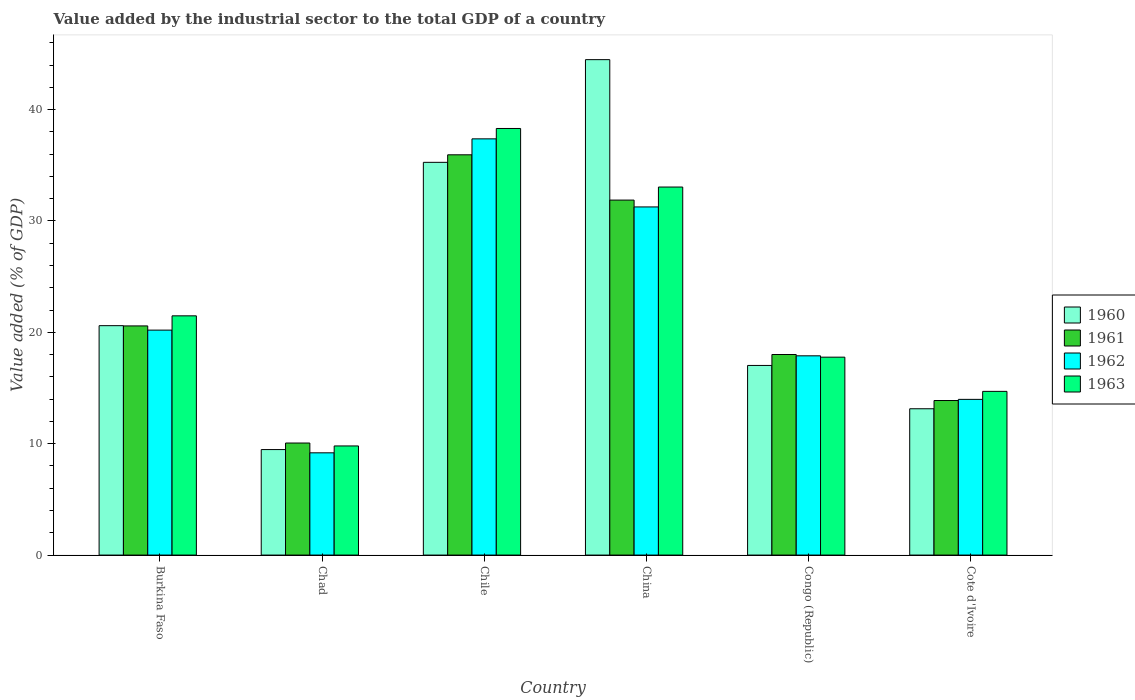How many groups of bars are there?
Provide a short and direct response. 6. Are the number of bars per tick equal to the number of legend labels?
Make the answer very short. Yes. How many bars are there on the 5th tick from the left?
Offer a terse response. 4. What is the value added by the industrial sector to the total GDP in 1961 in Chile?
Provide a short and direct response. 35.94. Across all countries, what is the maximum value added by the industrial sector to the total GDP in 1960?
Ensure brevity in your answer.  44.49. Across all countries, what is the minimum value added by the industrial sector to the total GDP in 1963?
Offer a terse response. 9.8. In which country was the value added by the industrial sector to the total GDP in 1960 minimum?
Make the answer very short. Chad. What is the total value added by the industrial sector to the total GDP in 1963 in the graph?
Your response must be concise. 135.11. What is the difference between the value added by the industrial sector to the total GDP in 1962 in Chile and that in China?
Your response must be concise. 6.11. What is the difference between the value added by the industrial sector to the total GDP in 1960 in Chile and the value added by the industrial sector to the total GDP in 1962 in Cote d'Ivoire?
Make the answer very short. 21.28. What is the average value added by the industrial sector to the total GDP in 1962 per country?
Your response must be concise. 21.65. What is the difference between the value added by the industrial sector to the total GDP of/in 1963 and value added by the industrial sector to the total GDP of/in 1960 in Chile?
Offer a very short reply. 3.04. In how many countries, is the value added by the industrial sector to the total GDP in 1961 greater than 14 %?
Your answer should be compact. 4. What is the ratio of the value added by the industrial sector to the total GDP in 1961 in Chile to that in China?
Offer a very short reply. 1.13. What is the difference between the highest and the second highest value added by the industrial sector to the total GDP in 1960?
Ensure brevity in your answer.  -9.22. What is the difference between the highest and the lowest value added by the industrial sector to the total GDP in 1961?
Keep it short and to the point. 25.88. In how many countries, is the value added by the industrial sector to the total GDP in 1963 greater than the average value added by the industrial sector to the total GDP in 1963 taken over all countries?
Make the answer very short. 2. Is the sum of the value added by the industrial sector to the total GDP in 1963 in Chile and Cote d'Ivoire greater than the maximum value added by the industrial sector to the total GDP in 1960 across all countries?
Ensure brevity in your answer.  Yes. What does the 3rd bar from the left in Congo (Republic) represents?
Make the answer very short. 1962. What does the 1st bar from the right in Burkina Faso represents?
Your answer should be very brief. 1963. Is it the case that in every country, the sum of the value added by the industrial sector to the total GDP in 1962 and value added by the industrial sector to the total GDP in 1963 is greater than the value added by the industrial sector to the total GDP in 1960?
Your answer should be compact. Yes. How many bars are there?
Offer a terse response. 24. Are all the bars in the graph horizontal?
Give a very brief answer. No. How many countries are there in the graph?
Ensure brevity in your answer.  6. Are the values on the major ticks of Y-axis written in scientific E-notation?
Ensure brevity in your answer.  No. Does the graph contain any zero values?
Your answer should be compact. No. Where does the legend appear in the graph?
Provide a succinct answer. Center right. How many legend labels are there?
Ensure brevity in your answer.  4. How are the legend labels stacked?
Offer a very short reply. Vertical. What is the title of the graph?
Your answer should be very brief. Value added by the industrial sector to the total GDP of a country. What is the label or title of the X-axis?
Your answer should be compact. Country. What is the label or title of the Y-axis?
Give a very brief answer. Value added (% of GDP). What is the Value added (% of GDP) of 1960 in Burkina Faso?
Your response must be concise. 20.6. What is the Value added (% of GDP) in 1961 in Burkina Faso?
Ensure brevity in your answer.  20.58. What is the Value added (% of GDP) of 1962 in Burkina Faso?
Provide a succinct answer. 20.2. What is the Value added (% of GDP) in 1963 in Burkina Faso?
Provide a succinct answer. 21.48. What is the Value added (% of GDP) of 1960 in Chad?
Your response must be concise. 9.47. What is the Value added (% of GDP) of 1961 in Chad?
Keep it short and to the point. 10.06. What is the Value added (% of GDP) of 1962 in Chad?
Your answer should be very brief. 9.18. What is the Value added (% of GDP) of 1963 in Chad?
Offer a very short reply. 9.8. What is the Value added (% of GDP) in 1960 in Chile?
Offer a very short reply. 35.27. What is the Value added (% of GDP) in 1961 in Chile?
Provide a short and direct response. 35.94. What is the Value added (% of GDP) of 1962 in Chile?
Your answer should be very brief. 37.38. What is the Value added (% of GDP) in 1963 in Chile?
Offer a terse response. 38.31. What is the Value added (% of GDP) in 1960 in China?
Keep it short and to the point. 44.49. What is the Value added (% of GDP) in 1961 in China?
Your answer should be very brief. 31.88. What is the Value added (% of GDP) of 1962 in China?
Make the answer very short. 31.26. What is the Value added (% of GDP) of 1963 in China?
Offer a terse response. 33.05. What is the Value added (% of GDP) in 1960 in Congo (Republic)?
Your answer should be compact. 17.03. What is the Value added (% of GDP) in 1961 in Congo (Republic)?
Give a very brief answer. 18.01. What is the Value added (% of GDP) in 1962 in Congo (Republic)?
Offer a very short reply. 17.89. What is the Value added (% of GDP) of 1963 in Congo (Republic)?
Make the answer very short. 17.77. What is the Value added (% of GDP) in 1960 in Cote d'Ivoire?
Make the answer very short. 13.14. What is the Value added (% of GDP) of 1961 in Cote d'Ivoire?
Give a very brief answer. 13.88. What is the Value added (% of GDP) of 1962 in Cote d'Ivoire?
Offer a terse response. 13.98. What is the Value added (% of GDP) in 1963 in Cote d'Ivoire?
Your answer should be compact. 14.7. Across all countries, what is the maximum Value added (% of GDP) of 1960?
Your response must be concise. 44.49. Across all countries, what is the maximum Value added (% of GDP) of 1961?
Your response must be concise. 35.94. Across all countries, what is the maximum Value added (% of GDP) of 1962?
Ensure brevity in your answer.  37.38. Across all countries, what is the maximum Value added (% of GDP) of 1963?
Offer a very short reply. 38.31. Across all countries, what is the minimum Value added (% of GDP) in 1960?
Make the answer very short. 9.47. Across all countries, what is the minimum Value added (% of GDP) of 1961?
Ensure brevity in your answer.  10.06. Across all countries, what is the minimum Value added (% of GDP) of 1962?
Your answer should be very brief. 9.18. Across all countries, what is the minimum Value added (% of GDP) in 1963?
Provide a succinct answer. 9.8. What is the total Value added (% of GDP) of 1960 in the graph?
Make the answer very short. 140. What is the total Value added (% of GDP) in 1961 in the graph?
Offer a very short reply. 130.35. What is the total Value added (% of GDP) in 1962 in the graph?
Provide a succinct answer. 129.9. What is the total Value added (% of GDP) of 1963 in the graph?
Your response must be concise. 135.11. What is the difference between the Value added (% of GDP) of 1960 in Burkina Faso and that in Chad?
Make the answer very short. 11.13. What is the difference between the Value added (% of GDP) in 1961 in Burkina Faso and that in Chad?
Provide a short and direct response. 10.52. What is the difference between the Value added (% of GDP) of 1962 in Burkina Faso and that in Chad?
Provide a short and direct response. 11.02. What is the difference between the Value added (% of GDP) in 1963 in Burkina Faso and that in Chad?
Provide a succinct answer. 11.68. What is the difference between the Value added (% of GDP) in 1960 in Burkina Faso and that in Chile?
Make the answer very short. -14.67. What is the difference between the Value added (% of GDP) in 1961 in Burkina Faso and that in Chile?
Make the answer very short. -15.37. What is the difference between the Value added (% of GDP) of 1962 in Burkina Faso and that in Chile?
Ensure brevity in your answer.  -17.18. What is the difference between the Value added (% of GDP) of 1963 in Burkina Faso and that in Chile?
Ensure brevity in your answer.  -16.82. What is the difference between the Value added (% of GDP) in 1960 in Burkina Faso and that in China?
Give a very brief answer. -23.89. What is the difference between the Value added (% of GDP) of 1961 in Burkina Faso and that in China?
Offer a terse response. -11.3. What is the difference between the Value added (% of GDP) in 1962 in Burkina Faso and that in China?
Offer a very short reply. -11.06. What is the difference between the Value added (% of GDP) of 1963 in Burkina Faso and that in China?
Offer a terse response. -11.57. What is the difference between the Value added (% of GDP) in 1960 in Burkina Faso and that in Congo (Republic)?
Ensure brevity in your answer.  3.57. What is the difference between the Value added (% of GDP) of 1961 in Burkina Faso and that in Congo (Republic)?
Provide a succinct answer. 2.57. What is the difference between the Value added (% of GDP) in 1962 in Burkina Faso and that in Congo (Republic)?
Your answer should be compact. 2.31. What is the difference between the Value added (% of GDP) of 1963 in Burkina Faso and that in Congo (Republic)?
Offer a terse response. 3.71. What is the difference between the Value added (% of GDP) in 1960 in Burkina Faso and that in Cote d'Ivoire?
Your answer should be very brief. 7.46. What is the difference between the Value added (% of GDP) in 1961 in Burkina Faso and that in Cote d'Ivoire?
Your response must be concise. 6.7. What is the difference between the Value added (% of GDP) of 1962 in Burkina Faso and that in Cote d'Ivoire?
Provide a succinct answer. 6.22. What is the difference between the Value added (% of GDP) in 1963 in Burkina Faso and that in Cote d'Ivoire?
Make the answer very short. 6.78. What is the difference between the Value added (% of GDP) in 1960 in Chad and that in Chile?
Provide a succinct answer. -25.79. What is the difference between the Value added (% of GDP) of 1961 in Chad and that in Chile?
Your answer should be compact. -25.88. What is the difference between the Value added (% of GDP) of 1962 in Chad and that in Chile?
Make the answer very short. -28.19. What is the difference between the Value added (% of GDP) of 1963 in Chad and that in Chile?
Your answer should be very brief. -28.51. What is the difference between the Value added (% of GDP) in 1960 in Chad and that in China?
Provide a short and direct response. -35.01. What is the difference between the Value added (% of GDP) in 1961 in Chad and that in China?
Provide a short and direct response. -21.81. What is the difference between the Value added (% of GDP) in 1962 in Chad and that in China?
Make the answer very short. -22.08. What is the difference between the Value added (% of GDP) of 1963 in Chad and that in China?
Your response must be concise. -23.25. What is the difference between the Value added (% of GDP) in 1960 in Chad and that in Congo (Republic)?
Give a very brief answer. -7.55. What is the difference between the Value added (% of GDP) of 1961 in Chad and that in Congo (Republic)?
Give a very brief answer. -7.95. What is the difference between the Value added (% of GDP) in 1962 in Chad and that in Congo (Republic)?
Offer a very short reply. -8.71. What is the difference between the Value added (% of GDP) of 1963 in Chad and that in Congo (Republic)?
Provide a short and direct response. -7.97. What is the difference between the Value added (% of GDP) of 1960 in Chad and that in Cote d'Ivoire?
Provide a succinct answer. -3.66. What is the difference between the Value added (% of GDP) of 1961 in Chad and that in Cote d'Ivoire?
Your response must be concise. -3.82. What is the difference between the Value added (% of GDP) in 1962 in Chad and that in Cote d'Ivoire?
Your answer should be very brief. -4.8. What is the difference between the Value added (% of GDP) of 1963 in Chad and that in Cote d'Ivoire?
Ensure brevity in your answer.  -4.9. What is the difference between the Value added (% of GDP) in 1960 in Chile and that in China?
Your response must be concise. -9.22. What is the difference between the Value added (% of GDP) in 1961 in Chile and that in China?
Your response must be concise. 4.07. What is the difference between the Value added (% of GDP) in 1962 in Chile and that in China?
Offer a terse response. 6.11. What is the difference between the Value added (% of GDP) in 1963 in Chile and that in China?
Offer a terse response. 5.26. What is the difference between the Value added (% of GDP) in 1960 in Chile and that in Congo (Republic)?
Your response must be concise. 18.24. What is the difference between the Value added (% of GDP) of 1961 in Chile and that in Congo (Republic)?
Provide a succinct answer. 17.93. What is the difference between the Value added (% of GDP) of 1962 in Chile and that in Congo (Republic)?
Keep it short and to the point. 19.48. What is the difference between the Value added (% of GDP) in 1963 in Chile and that in Congo (Republic)?
Provide a succinct answer. 20.54. What is the difference between the Value added (% of GDP) in 1960 in Chile and that in Cote d'Ivoire?
Make the answer very short. 22.13. What is the difference between the Value added (% of GDP) in 1961 in Chile and that in Cote d'Ivoire?
Provide a succinct answer. 22.06. What is the difference between the Value added (% of GDP) in 1962 in Chile and that in Cote d'Ivoire?
Offer a terse response. 23.39. What is the difference between the Value added (% of GDP) in 1963 in Chile and that in Cote d'Ivoire?
Your response must be concise. 23.61. What is the difference between the Value added (% of GDP) of 1960 in China and that in Congo (Republic)?
Offer a terse response. 27.46. What is the difference between the Value added (% of GDP) of 1961 in China and that in Congo (Republic)?
Your answer should be very brief. 13.87. What is the difference between the Value added (% of GDP) of 1962 in China and that in Congo (Republic)?
Your response must be concise. 13.37. What is the difference between the Value added (% of GDP) in 1963 in China and that in Congo (Republic)?
Offer a very short reply. 15.28. What is the difference between the Value added (% of GDP) in 1960 in China and that in Cote d'Ivoire?
Make the answer very short. 31.35. What is the difference between the Value added (% of GDP) in 1961 in China and that in Cote d'Ivoire?
Make the answer very short. 18. What is the difference between the Value added (% of GDP) in 1962 in China and that in Cote d'Ivoire?
Ensure brevity in your answer.  17.28. What is the difference between the Value added (% of GDP) in 1963 in China and that in Cote d'Ivoire?
Provide a short and direct response. 18.35. What is the difference between the Value added (% of GDP) of 1960 in Congo (Republic) and that in Cote d'Ivoire?
Make the answer very short. 3.89. What is the difference between the Value added (% of GDP) in 1961 in Congo (Republic) and that in Cote d'Ivoire?
Provide a short and direct response. 4.13. What is the difference between the Value added (% of GDP) in 1962 in Congo (Republic) and that in Cote d'Ivoire?
Make the answer very short. 3.91. What is the difference between the Value added (% of GDP) in 1963 in Congo (Republic) and that in Cote d'Ivoire?
Make the answer very short. 3.07. What is the difference between the Value added (% of GDP) in 1960 in Burkina Faso and the Value added (% of GDP) in 1961 in Chad?
Your response must be concise. 10.54. What is the difference between the Value added (% of GDP) of 1960 in Burkina Faso and the Value added (% of GDP) of 1962 in Chad?
Your answer should be compact. 11.42. What is the difference between the Value added (% of GDP) of 1960 in Burkina Faso and the Value added (% of GDP) of 1963 in Chad?
Give a very brief answer. 10.8. What is the difference between the Value added (% of GDP) in 1961 in Burkina Faso and the Value added (% of GDP) in 1962 in Chad?
Offer a very short reply. 11.4. What is the difference between the Value added (% of GDP) in 1961 in Burkina Faso and the Value added (% of GDP) in 1963 in Chad?
Keep it short and to the point. 10.78. What is the difference between the Value added (% of GDP) of 1962 in Burkina Faso and the Value added (% of GDP) of 1963 in Chad?
Give a very brief answer. 10.4. What is the difference between the Value added (% of GDP) of 1960 in Burkina Faso and the Value added (% of GDP) of 1961 in Chile?
Offer a terse response. -15.34. What is the difference between the Value added (% of GDP) in 1960 in Burkina Faso and the Value added (% of GDP) in 1962 in Chile?
Give a very brief answer. -16.78. What is the difference between the Value added (% of GDP) in 1960 in Burkina Faso and the Value added (% of GDP) in 1963 in Chile?
Your response must be concise. -17.71. What is the difference between the Value added (% of GDP) of 1961 in Burkina Faso and the Value added (% of GDP) of 1962 in Chile?
Make the answer very short. -16.8. What is the difference between the Value added (% of GDP) in 1961 in Burkina Faso and the Value added (% of GDP) in 1963 in Chile?
Provide a succinct answer. -17.73. What is the difference between the Value added (% of GDP) of 1962 in Burkina Faso and the Value added (% of GDP) of 1963 in Chile?
Your answer should be compact. -18.11. What is the difference between the Value added (% of GDP) in 1960 in Burkina Faso and the Value added (% of GDP) in 1961 in China?
Keep it short and to the point. -11.28. What is the difference between the Value added (% of GDP) of 1960 in Burkina Faso and the Value added (% of GDP) of 1962 in China?
Provide a succinct answer. -10.66. What is the difference between the Value added (% of GDP) of 1960 in Burkina Faso and the Value added (% of GDP) of 1963 in China?
Provide a short and direct response. -12.45. What is the difference between the Value added (% of GDP) of 1961 in Burkina Faso and the Value added (% of GDP) of 1962 in China?
Provide a short and direct response. -10.68. What is the difference between the Value added (% of GDP) of 1961 in Burkina Faso and the Value added (% of GDP) of 1963 in China?
Your response must be concise. -12.47. What is the difference between the Value added (% of GDP) in 1962 in Burkina Faso and the Value added (% of GDP) in 1963 in China?
Offer a terse response. -12.85. What is the difference between the Value added (% of GDP) of 1960 in Burkina Faso and the Value added (% of GDP) of 1961 in Congo (Republic)?
Your answer should be compact. 2.59. What is the difference between the Value added (% of GDP) of 1960 in Burkina Faso and the Value added (% of GDP) of 1962 in Congo (Republic)?
Keep it short and to the point. 2.71. What is the difference between the Value added (% of GDP) of 1960 in Burkina Faso and the Value added (% of GDP) of 1963 in Congo (Republic)?
Your answer should be compact. 2.83. What is the difference between the Value added (% of GDP) of 1961 in Burkina Faso and the Value added (% of GDP) of 1962 in Congo (Republic)?
Ensure brevity in your answer.  2.69. What is the difference between the Value added (% of GDP) in 1961 in Burkina Faso and the Value added (% of GDP) in 1963 in Congo (Republic)?
Make the answer very short. 2.81. What is the difference between the Value added (% of GDP) of 1962 in Burkina Faso and the Value added (% of GDP) of 1963 in Congo (Republic)?
Keep it short and to the point. 2.43. What is the difference between the Value added (% of GDP) in 1960 in Burkina Faso and the Value added (% of GDP) in 1961 in Cote d'Ivoire?
Offer a terse response. 6.72. What is the difference between the Value added (% of GDP) of 1960 in Burkina Faso and the Value added (% of GDP) of 1962 in Cote d'Ivoire?
Provide a short and direct response. 6.62. What is the difference between the Value added (% of GDP) of 1960 in Burkina Faso and the Value added (% of GDP) of 1963 in Cote d'Ivoire?
Provide a short and direct response. 5.9. What is the difference between the Value added (% of GDP) in 1961 in Burkina Faso and the Value added (% of GDP) in 1962 in Cote d'Ivoire?
Offer a terse response. 6.6. What is the difference between the Value added (% of GDP) of 1961 in Burkina Faso and the Value added (% of GDP) of 1963 in Cote d'Ivoire?
Your response must be concise. 5.88. What is the difference between the Value added (% of GDP) in 1962 in Burkina Faso and the Value added (% of GDP) in 1963 in Cote d'Ivoire?
Ensure brevity in your answer.  5.5. What is the difference between the Value added (% of GDP) of 1960 in Chad and the Value added (% of GDP) of 1961 in Chile?
Give a very brief answer. -26.47. What is the difference between the Value added (% of GDP) in 1960 in Chad and the Value added (% of GDP) in 1962 in Chile?
Ensure brevity in your answer.  -27.9. What is the difference between the Value added (% of GDP) of 1960 in Chad and the Value added (% of GDP) of 1963 in Chile?
Offer a terse response. -28.83. What is the difference between the Value added (% of GDP) in 1961 in Chad and the Value added (% of GDP) in 1962 in Chile?
Ensure brevity in your answer.  -27.31. What is the difference between the Value added (% of GDP) of 1961 in Chad and the Value added (% of GDP) of 1963 in Chile?
Ensure brevity in your answer.  -28.25. What is the difference between the Value added (% of GDP) in 1962 in Chad and the Value added (% of GDP) in 1963 in Chile?
Your response must be concise. -29.13. What is the difference between the Value added (% of GDP) in 1960 in Chad and the Value added (% of GDP) in 1961 in China?
Make the answer very short. -22.4. What is the difference between the Value added (% of GDP) of 1960 in Chad and the Value added (% of GDP) of 1962 in China?
Provide a succinct answer. -21.79. What is the difference between the Value added (% of GDP) of 1960 in Chad and the Value added (% of GDP) of 1963 in China?
Offer a very short reply. -23.58. What is the difference between the Value added (% of GDP) in 1961 in Chad and the Value added (% of GDP) in 1962 in China?
Provide a succinct answer. -21.2. What is the difference between the Value added (% of GDP) of 1961 in Chad and the Value added (% of GDP) of 1963 in China?
Ensure brevity in your answer.  -22.99. What is the difference between the Value added (% of GDP) in 1962 in Chad and the Value added (% of GDP) in 1963 in China?
Make the answer very short. -23.87. What is the difference between the Value added (% of GDP) in 1960 in Chad and the Value added (% of GDP) in 1961 in Congo (Republic)?
Keep it short and to the point. -8.54. What is the difference between the Value added (% of GDP) in 1960 in Chad and the Value added (% of GDP) in 1962 in Congo (Republic)?
Make the answer very short. -8.42. What is the difference between the Value added (% of GDP) in 1960 in Chad and the Value added (% of GDP) in 1963 in Congo (Republic)?
Provide a short and direct response. -8.3. What is the difference between the Value added (% of GDP) in 1961 in Chad and the Value added (% of GDP) in 1962 in Congo (Republic)?
Ensure brevity in your answer.  -7.83. What is the difference between the Value added (% of GDP) of 1961 in Chad and the Value added (% of GDP) of 1963 in Congo (Republic)?
Your answer should be very brief. -7.71. What is the difference between the Value added (% of GDP) of 1962 in Chad and the Value added (% of GDP) of 1963 in Congo (Republic)?
Keep it short and to the point. -8.59. What is the difference between the Value added (% of GDP) in 1960 in Chad and the Value added (% of GDP) in 1961 in Cote d'Ivoire?
Offer a very short reply. -4.4. What is the difference between the Value added (% of GDP) in 1960 in Chad and the Value added (% of GDP) in 1962 in Cote d'Ivoire?
Provide a succinct answer. -4.51. What is the difference between the Value added (% of GDP) of 1960 in Chad and the Value added (% of GDP) of 1963 in Cote d'Ivoire?
Provide a short and direct response. -5.23. What is the difference between the Value added (% of GDP) of 1961 in Chad and the Value added (% of GDP) of 1962 in Cote d'Ivoire?
Ensure brevity in your answer.  -3.92. What is the difference between the Value added (% of GDP) of 1961 in Chad and the Value added (% of GDP) of 1963 in Cote d'Ivoire?
Your answer should be compact. -4.64. What is the difference between the Value added (% of GDP) in 1962 in Chad and the Value added (% of GDP) in 1963 in Cote d'Ivoire?
Your answer should be compact. -5.52. What is the difference between the Value added (% of GDP) of 1960 in Chile and the Value added (% of GDP) of 1961 in China?
Give a very brief answer. 3.39. What is the difference between the Value added (% of GDP) in 1960 in Chile and the Value added (% of GDP) in 1962 in China?
Give a very brief answer. 4. What is the difference between the Value added (% of GDP) in 1960 in Chile and the Value added (% of GDP) in 1963 in China?
Offer a terse response. 2.22. What is the difference between the Value added (% of GDP) in 1961 in Chile and the Value added (% of GDP) in 1962 in China?
Provide a short and direct response. 4.68. What is the difference between the Value added (% of GDP) of 1961 in Chile and the Value added (% of GDP) of 1963 in China?
Your response must be concise. 2.89. What is the difference between the Value added (% of GDP) of 1962 in Chile and the Value added (% of GDP) of 1963 in China?
Keep it short and to the point. 4.33. What is the difference between the Value added (% of GDP) in 1960 in Chile and the Value added (% of GDP) in 1961 in Congo (Republic)?
Offer a very short reply. 17.26. What is the difference between the Value added (% of GDP) of 1960 in Chile and the Value added (% of GDP) of 1962 in Congo (Republic)?
Your answer should be compact. 17.37. What is the difference between the Value added (% of GDP) in 1960 in Chile and the Value added (% of GDP) in 1963 in Congo (Republic)?
Provide a short and direct response. 17.49. What is the difference between the Value added (% of GDP) of 1961 in Chile and the Value added (% of GDP) of 1962 in Congo (Republic)?
Give a very brief answer. 18.05. What is the difference between the Value added (% of GDP) in 1961 in Chile and the Value added (% of GDP) in 1963 in Congo (Republic)?
Ensure brevity in your answer.  18.17. What is the difference between the Value added (% of GDP) in 1962 in Chile and the Value added (% of GDP) in 1963 in Congo (Republic)?
Provide a short and direct response. 19.6. What is the difference between the Value added (% of GDP) of 1960 in Chile and the Value added (% of GDP) of 1961 in Cote d'Ivoire?
Keep it short and to the point. 21.39. What is the difference between the Value added (% of GDP) of 1960 in Chile and the Value added (% of GDP) of 1962 in Cote d'Ivoire?
Make the answer very short. 21.28. What is the difference between the Value added (% of GDP) of 1960 in Chile and the Value added (% of GDP) of 1963 in Cote d'Ivoire?
Offer a very short reply. 20.57. What is the difference between the Value added (% of GDP) of 1961 in Chile and the Value added (% of GDP) of 1962 in Cote d'Ivoire?
Offer a very short reply. 21.96. What is the difference between the Value added (% of GDP) in 1961 in Chile and the Value added (% of GDP) in 1963 in Cote d'Ivoire?
Provide a succinct answer. 21.24. What is the difference between the Value added (% of GDP) in 1962 in Chile and the Value added (% of GDP) in 1963 in Cote d'Ivoire?
Provide a short and direct response. 22.68. What is the difference between the Value added (% of GDP) of 1960 in China and the Value added (% of GDP) of 1961 in Congo (Republic)?
Your answer should be very brief. 26.48. What is the difference between the Value added (% of GDP) in 1960 in China and the Value added (% of GDP) in 1962 in Congo (Republic)?
Your response must be concise. 26.6. What is the difference between the Value added (% of GDP) of 1960 in China and the Value added (% of GDP) of 1963 in Congo (Republic)?
Your response must be concise. 26.72. What is the difference between the Value added (% of GDP) of 1961 in China and the Value added (% of GDP) of 1962 in Congo (Republic)?
Offer a terse response. 13.98. What is the difference between the Value added (% of GDP) of 1961 in China and the Value added (% of GDP) of 1963 in Congo (Republic)?
Your answer should be very brief. 14.1. What is the difference between the Value added (% of GDP) of 1962 in China and the Value added (% of GDP) of 1963 in Congo (Republic)?
Your answer should be compact. 13.49. What is the difference between the Value added (% of GDP) in 1960 in China and the Value added (% of GDP) in 1961 in Cote d'Ivoire?
Offer a very short reply. 30.61. What is the difference between the Value added (% of GDP) in 1960 in China and the Value added (% of GDP) in 1962 in Cote d'Ivoire?
Provide a short and direct response. 30.51. What is the difference between the Value added (% of GDP) of 1960 in China and the Value added (% of GDP) of 1963 in Cote d'Ivoire?
Your answer should be compact. 29.79. What is the difference between the Value added (% of GDP) of 1961 in China and the Value added (% of GDP) of 1962 in Cote d'Ivoire?
Offer a very short reply. 17.9. What is the difference between the Value added (% of GDP) of 1961 in China and the Value added (% of GDP) of 1963 in Cote d'Ivoire?
Offer a very short reply. 17.18. What is the difference between the Value added (% of GDP) in 1962 in China and the Value added (% of GDP) in 1963 in Cote d'Ivoire?
Your answer should be compact. 16.56. What is the difference between the Value added (% of GDP) of 1960 in Congo (Republic) and the Value added (% of GDP) of 1961 in Cote d'Ivoire?
Your response must be concise. 3.15. What is the difference between the Value added (% of GDP) of 1960 in Congo (Republic) and the Value added (% of GDP) of 1962 in Cote d'Ivoire?
Your answer should be compact. 3.05. What is the difference between the Value added (% of GDP) in 1960 in Congo (Republic) and the Value added (% of GDP) in 1963 in Cote d'Ivoire?
Offer a terse response. 2.33. What is the difference between the Value added (% of GDP) in 1961 in Congo (Republic) and the Value added (% of GDP) in 1962 in Cote d'Ivoire?
Provide a short and direct response. 4.03. What is the difference between the Value added (% of GDP) of 1961 in Congo (Republic) and the Value added (% of GDP) of 1963 in Cote d'Ivoire?
Offer a terse response. 3.31. What is the difference between the Value added (% of GDP) in 1962 in Congo (Republic) and the Value added (% of GDP) in 1963 in Cote d'Ivoire?
Make the answer very short. 3.19. What is the average Value added (% of GDP) in 1960 per country?
Your answer should be compact. 23.33. What is the average Value added (% of GDP) of 1961 per country?
Provide a succinct answer. 21.73. What is the average Value added (% of GDP) in 1962 per country?
Give a very brief answer. 21.65. What is the average Value added (% of GDP) of 1963 per country?
Keep it short and to the point. 22.52. What is the difference between the Value added (% of GDP) in 1960 and Value added (% of GDP) in 1961 in Burkina Faso?
Provide a short and direct response. 0.02. What is the difference between the Value added (% of GDP) in 1960 and Value added (% of GDP) in 1962 in Burkina Faso?
Offer a terse response. 0.4. What is the difference between the Value added (% of GDP) of 1960 and Value added (% of GDP) of 1963 in Burkina Faso?
Provide a short and direct response. -0.88. What is the difference between the Value added (% of GDP) of 1961 and Value added (% of GDP) of 1962 in Burkina Faso?
Your response must be concise. 0.38. What is the difference between the Value added (% of GDP) in 1961 and Value added (% of GDP) in 1963 in Burkina Faso?
Offer a terse response. -0.91. What is the difference between the Value added (% of GDP) of 1962 and Value added (% of GDP) of 1963 in Burkina Faso?
Your answer should be compact. -1.28. What is the difference between the Value added (% of GDP) of 1960 and Value added (% of GDP) of 1961 in Chad?
Your answer should be compact. -0.59. What is the difference between the Value added (% of GDP) of 1960 and Value added (% of GDP) of 1962 in Chad?
Offer a very short reply. 0.29. What is the difference between the Value added (% of GDP) of 1960 and Value added (% of GDP) of 1963 in Chad?
Provide a succinct answer. -0.32. What is the difference between the Value added (% of GDP) of 1961 and Value added (% of GDP) of 1962 in Chad?
Give a very brief answer. 0.88. What is the difference between the Value added (% of GDP) of 1961 and Value added (% of GDP) of 1963 in Chad?
Provide a succinct answer. 0.26. What is the difference between the Value added (% of GDP) in 1962 and Value added (% of GDP) in 1963 in Chad?
Make the answer very short. -0.62. What is the difference between the Value added (% of GDP) of 1960 and Value added (% of GDP) of 1961 in Chile?
Provide a short and direct response. -0.68. What is the difference between the Value added (% of GDP) of 1960 and Value added (% of GDP) of 1962 in Chile?
Ensure brevity in your answer.  -2.11. What is the difference between the Value added (% of GDP) of 1960 and Value added (% of GDP) of 1963 in Chile?
Offer a very short reply. -3.04. What is the difference between the Value added (% of GDP) of 1961 and Value added (% of GDP) of 1962 in Chile?
Your answer should be compact. -1.43. What is the difference between the Value added (% of GDP) in 1961 and Value added (% of GDP) in 1963 in Chile?
Offer a terse response. -2.36. What is the difference between the Value added (% of GDP) of 1962 and Value added (% of GDP) of 1963 in Chile?
Your answer should be very brief. -0.93. What is the difference between the Value added (% of GDP) in 1960 and Value added (% of GDP) in 1961 in China?
Your answer should be compact. 12.61. What is the difference between the Value added (% of GDP) of 1960 and Value added (% of GDP) of 1962 in China?
Ensure brevity in your answer.  13.23. What is the difference between the Value added (% of GDP) in 1960 and Value added (% of GDP) in 1963 in China?
Ensure brevity in your answer.  11.44. What is the difference between the Value added (% of GDP) of 1961 and Value added (% of GDP) of 1962 in China?
Your answer should be very brief. 0.61. What is the difference between the Value added (% of GDP) of 1961 and Value added (% of GDP) of 1963 in China?
Provide a short and direct response. -1.17. What is the difference between the Value added (% of GDP) of 1962 and Value added (% of GDP) of 1963 in China?
Provide a succinct answer. -1.79. What is the difference between the Value added (% of GDP) in 1960 and Value added (% of GDP) in 1961 in Congo (Republic)?
Make the answer very short. -0.98. What is the difference between the Value added (% of GDP) in 1960 and Value added (% of GDP) in 1962 in Congo (Republic)?
Provide a short and direct response. -0.86. What is the difference between the Value added (% of GDP) in 1960 and Value added (% of GDP) in 1963 in Congo (Republic)?
Offer a terse response. -0.74. What is the difference between the Value added (% of GDP) in 1961 and Value added (% of GDP) in 1962 in Congo (Republic)?
Your answer should be compact. 0.12. What is the difference between the Value added (% of GDP) of 1961 and Value added (% of GDP) of 1963 in Congo (Republic)?
Offer a very short reply. 0.24. What is the difference between the Value added (% of GDP) of 1962 and Value added (% of GDP) of 1963 in Congo (Republic)?
Offer a very short reply. 0.12. What is the difference between the Value added (% of GDP) of 1960 and Value added (% of GDP) of 1961 in Cote d'Ivoire?
Give a very brief answer. -0.74. What is the difference between the Value added (% of GDP) in 1960 and Value added (% of GDP) in 1962 in Cote d'Ivoire?
Ensure brevity in your answer.  -0.84. What is the difference between the Value added (% of GDP) of 1960 and Value added (% of GDP) of 1963 in Cote d'Ivoire?
Provide a short and direct response. -1.56. What is the difference between the Value added (% of GDP) of 1961 and Value added (% of GDP) of 1962 in Cote d'Ivoire?
Offer a very short reply. -0.1. What is the difference between the Value added (% of GDP) in 1961 and Value added (% of GDP) in 1963 in Cote d'Ivoire?
Provide a succinct answer. -0.82. What is the difference between the Value added (% of GDP) in 1962 and Value added (% of GDP) in 1963 in Cote d'Ivoire?
Your answer should be compact. -0.72. What is the ratio of the Value added (% of GDP) of 1960 in Burkina Faso to that in Chad?
Provide a succinct answer. 2.17. What is the ratio of the Value added (% of GDP) in 1961 in Burkina Faso to that in Chad?
Offer a terse response. 2.04. What is the ratio of the Value added (% of GDP) of 1963 in Burkina Faso to that in Chad?
Offer a very short reply. 2.19. What is the ratio of the Value added (% of GDP) in 1960 in Burkina Faso to that in Chile?
Your answer should be compact. 0.58. What is the ratio of the Value added (% of GDP) of 1961 in Burkina Faso to that in Chile?
Your response must be concise. 0.57. What is the ratio of the Value added (% of GDP) of 1962 in Burkina Faso to that in Chile?
Ensure brevity in your answer.  0.54. What is the ratio of the Value added (% of GDP) of 1963 in Burkina Faso to that in Chile?
Make the answer very short. 0.56. What is the ratio of the Value added (% of GDP) in 1960 in Burkina Faso to that in China?
Offer a terse response. 0.46. What is the ratio of the Value added (% of GDP) of 1961 in Burkina Faso to that in China?
Your answer should be very brief. 0.65. What is the ratio of the Value added (% of GDP) of 1962 in Burkina Faso to that in China?
Your response must be concise. 0.65. What is the ratio of the Value added (% of GDP) in 1963 in Burkina Faso to that in China?
Keep it short and to the point. 0.65. What is the ratio of the Value added (% of GDP) in 1960 in Burkina Faso to that in Congo (Republic)?
Your answer should be compact. 1.21. What is the ratio of the Value added (% of GDP) in 1961 in Burkina Faso to that in Congo (Republic)?
Provide a succinct answer. 1.14. What is the ratio of the Value added (% of GDP) of 1962 in Burkina Faso to that in Congo (Republic)?
Your answer should be compact. 1.13. What is the ratio of the Value added (% of GDP) in 1963 in Burkina Faso to that in Congo (Republic)?
Offer a very short reply. 1.21. What is the ratio of the Value added (% of GDP) in 1960 in Burkina Faso to that in Cote d'Ivoire?
Provide a short and direct response. 1.57. What is the ratio of the Value added (% of GDP) in 1961 in Burkina Faso to that in Cote d'Ivoire?
Keep it short and to the point. 1.48. What is the ratio of the Value added (% of GDP) in 1962 in Burkina Faso to that in Cote d'Ivoire?
Ensure brevity in your answer.  1.44. What is the ratio of the Value added (% of GDP) of 1963 in Burkina Faso to that in Cote d'Ivoire?
Keep it short and to the point. 1.46. What is the ratio of the Value added (% of GDP) of 1960 in Chad to that in Chile?
Give a very brief answer. 0.27. What is the ratio of the Value added (% of GDP) in 1961 in Chad to that in Chile?
Your answer should be compact. 0.28. What is the ratio of the Value added (% of GDP) of 1962 in Chad to that in Chile?
Keep it short and to the point. 0.25. What is the ratio of the Value added (% of GDP) of 1963 in Chad to that in Chile?
Offer a very short reply. 0.26. What is the ratio of the Value added (% of GDP) in 1960 in Chad to that in China?
Offer a very short reply. 0.21. What is the ratio of the Value added (% of GDP) in 1961 in Chad to that in China?
Offer a very short reply. 0.32. What is the ratio of the Value added (% of GDP) of 1962 in Chad to that in China?
Your response must be concise. 0.29. What is the ratio of the Value added (% of GDP) of 1963 in Chad to that in China?
Keep it short and to the point. 0.3. What is the ratio of the Value added (% of GDP) of 1960 in Chad to that in Congo (Republic)?
Provide a short and direct response. 0.56. What is the ratio of the Value added (% of GDP) in 1961 in Chad to that in Congo (Republic)?
Ensure brevity in your answer.  0.56. What is the ratio of the Value added (% of GDP) in 1962 in Chad to that in Congo (Republic)?
Keep it short and to the point. 0.51. What is the ratio of the Value added (% of GDP) of 1963 in Chad to that in Congo (Republic)?
Offer a terse response. 0.55. What is the ratio of the Value added (% of GDP) in 1960 in Chad to that in Cote d'Ivoire?
Ensure brevity in your answer.  0.72. What is the ratio of the Value added (% of GDP) in 1961 in Chad to that in Cote d'Ivoire?
Your answer should be very brief. 0.72. What is the ratio of the Value added (% of GDP) of 1962 in Chad to that in Cote d'Ivoire?
Ensure brevity in your answer.  0.66. What is the ratio of the Value added (% of GDP) of 1963 in Chad to that in Cote d'Ivoire?
Offer a terse response. 0.67. What is the ratio of the Value added (% of GDP) of 1960 in Chile to that in China?
Offer a very short reply. 0.79. What is the ratio of the Value added (% of GDP) in 1961 in Chile to that in China?
Provide a succinct answer. 1.13. What is the ratio of the Value added (% of GDP) in 1962 in Chile to that in China?
Make the answer very short. 1.2. What is the ratio of the Value added (% of GDP) in 1963 in Chile to that in China?
Your answer should be compact. 1.16. What is the ratio of the Value added (% of GDP) in 1960 in Chile to that in Congo (Republic)?
Offer a terse response. 2.07. What is the ratio of the Value added (% of GDP) of 1961 in Chile to that in Congo (Republic)?
Offer a very short reply. 2. What is the ratio of the Value added (% of GDP) of 1962 in Chile to that in Congo (Republic)?
Give a very brief answer. 2.09. What is the ratio of the Value added (% of GDP) in 1963 in Chile to that in Congo (Republic)?
Ensure brevity in your answer.  2.16. What is the ratio of the Value added (% of GDP) of 1960 in Chile to that in Cote d'Ivoire?
Your answer should be compact. 2.68. What is the ratio of the Value added (% of GDP) of 1961 in Chile to that in Cote d'Ivoire?
Offer a very short reply. 2.59. What is the ratio of the Value added (% of GDP) in 1962 in Chile to that in Cote d'Ivoire?
Ensure brevity in your answer.  2.67. What is the ratio of the Value added (% of GDP) in 1963 in Chile to that in Cote d'Ivoire?
Give a very brief answer. 2.61. What is the ratio of the Value added (% of GDP) of 1960 in China to that in Congo (Republic)?
Provide a short and direct response. 2.61. What is the ratio of the Value added (% of GDP) of 1961 in China to that in Congo (Republic)?
Make the answer very short. 1.77. What is the ratio of the Value added (% of GDP) of 1962 in China to that in Congo (Republic)?
Give a very brief answer. 1.75. What is the ratio of the Value added (% of GDP) of 1963 in China to that in Congo (Republic)?
Give a very brief answer. 1.86. What is the ratio of the Value added (% of GDP) of 1960 in China to that in Cote d'Ivoire?
Provide a succinct answer. 3.39. What is the ratio of the Value added (% of GDP) of 1961 in China to that in Cote d'Ivoire?
Your answer should be compact. 2.3. What is the ratio of the Value added (% of GDP) in 1962 in China to that in Cote d'Ivoire?
Ensure brevity in your answer.  2.24. What is the ratio of the Value added (% of GDP) in 1963 in China to that in Cote d'Ivoire?
Ensure brevity in your answer.  2.25. What is the ratio of the Value added (% of GDP) in 1960 in Congo (Republic) to that in Cote d'Ivoire?
Provide a short and direct response. 1.3. What is the ratio of the Value added (% of GDP) in 1961 in Congo (Republic) to that in Cote d'Ivoire?
Ensure brevity in your answer.  1.3. What is the ratio of the Value added (% of GDP) in 1962 in Congo (Republic) to that in Cote d'Ivoire?
Your answer should be compact. 1.28. What is the ratio of the Value added (% of GDP) of 1963 in Congo (Republic) to that in Cote d'Ivoire?
Your answer should be very brief. 1.21. What is the difference between the highest and the second highest Value added (% of GDP) of 1960?
Provide a short and direct response. 9.22. What is the difference between the highest and the second highest Value added (% of GDP) in 1961?
Your response must be concise. 4.07. What is the difference between the highest and the second highest Value added (% of GDP) in 1962?
Provide a short and direct response. 6.11. What is the difference between the highest and the second highest Value added (% of GDP) in 1963?
Provide a short and direct response. 5.26. What is the difference between the highest and the lowest Value added (% of GDP) in 1960?
Give a very brief answer. 35.01. What is the difference between the highest and the lowest Value added (% of GDP) in 1961?
Your answer should be compact. 25.88. What is the difference between the highest and the lowest Value added (% of GDP) in 1962?
Your answer should be compact. 28.19. What is the difference between the highest and the lowest Value added (% of GDP) of 1963?
Your response must be concise. 28.51. 